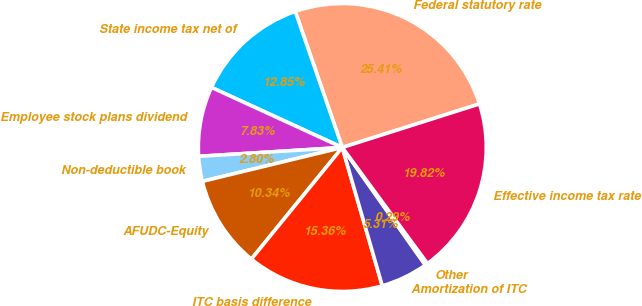Convert chart. <chart><loc_0><loc_0><loc_500><loc_500><pie_chart><fcel>Federal statutory rate<fcel>State income tax net of<fcel>Employee stock plans dividend<fcel>Non-deductible book<fcel>AFUDC-Equity<fcel>ITC basis difference<fcel>Amortization of ITC<fcel>Other<fcel>Effective income tax rate<nl><fcel>25.41%<fcel>12.85%<fcel>7.83%<fcel>2.8%<fcel>10.34%<fcel>15.36%<fcel>5.31%<fcel>0.29%<fcel>19.82%<nl></chart> 